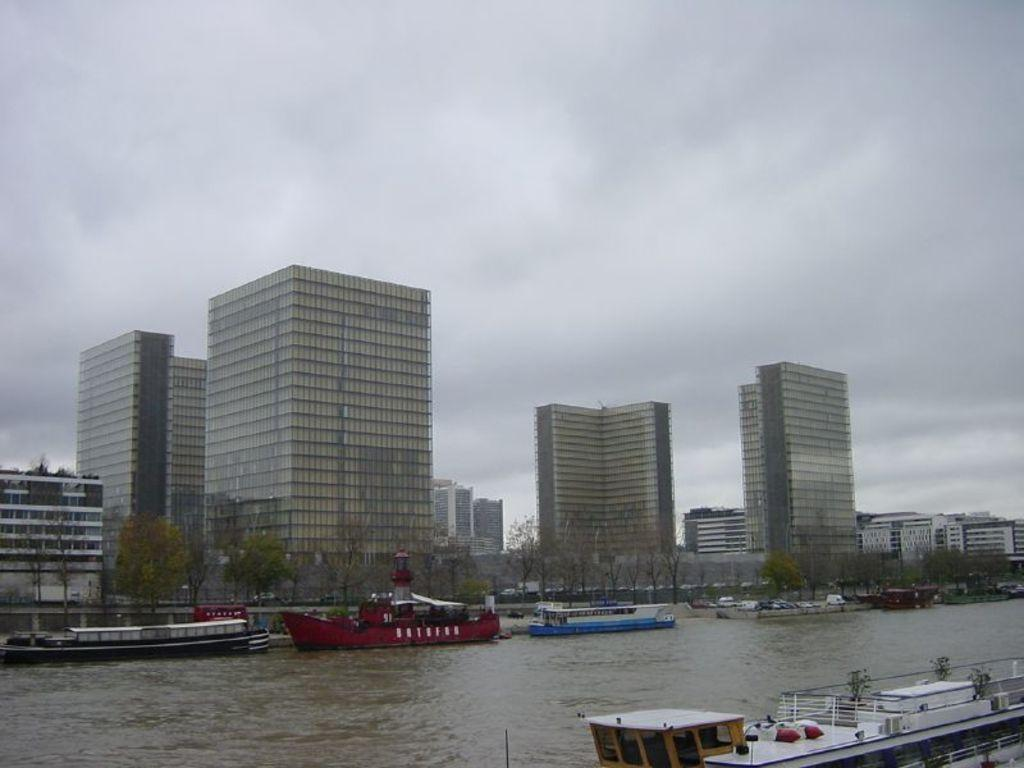What is on the water in the image? There are boats on the water in the image. What type of vegetation can be seen in the image? There are trees and plants in the image. What type of structures are visible in the image? There are buildings in the image. What can be seen in the background of the image? The sky is visible in the background of the image. What type of meal is being prepared on the boats in the image? There is no indication of a meal being prepared on the boats in the image. Can you see a kite flying in the sky in the image? There is no kite visible in the image; only the boats, trees, plants, buildings, and sky are present. 